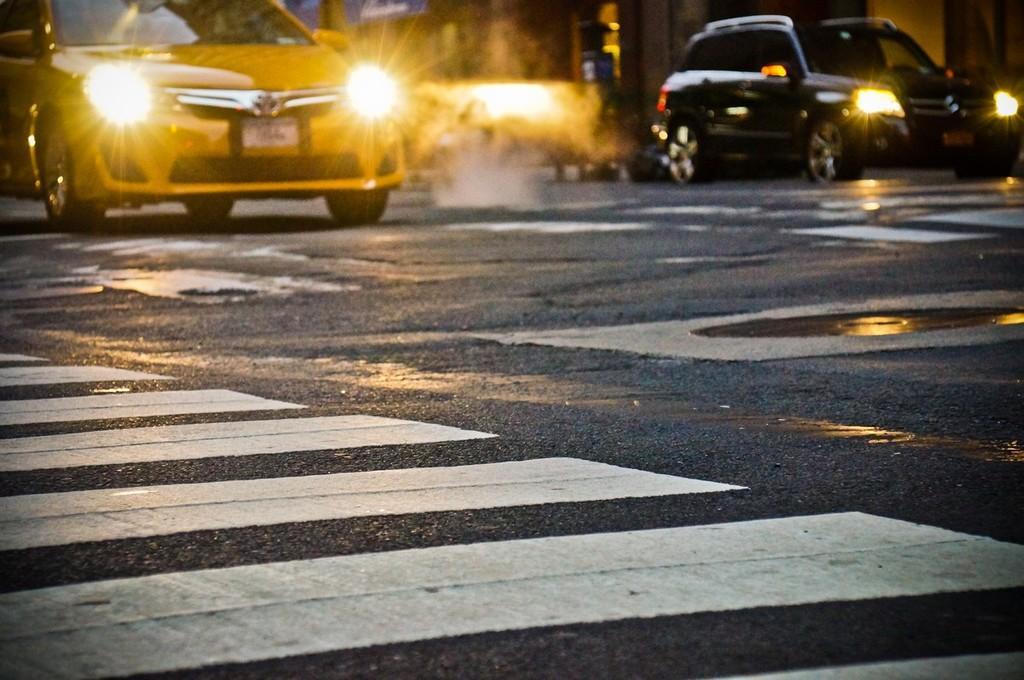In one or two sentences, can you explain what this image depicts? On the top I can see fleets of cars on the road. This image is taken during night on the road. 